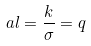<formula> <loc_0><loc_0><loc_500><loc_500>a l = \frac { k } { \sigma } = q</formula> 